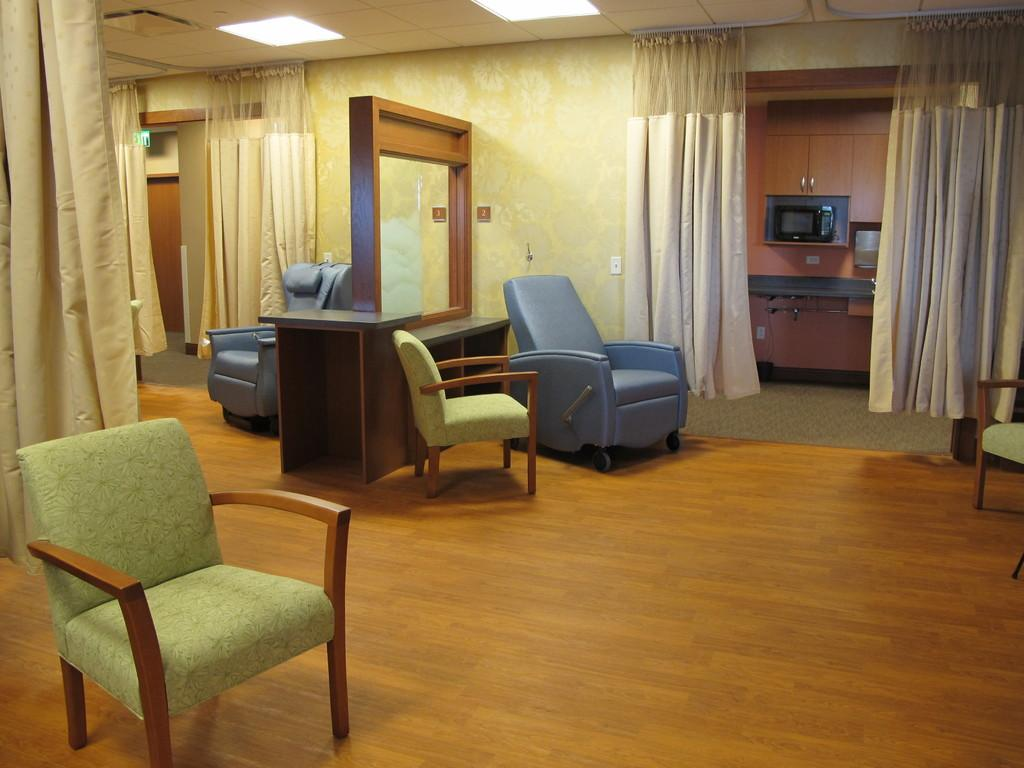What type of furniture is present in the image? There are chairs and a sofa in the image. What type of window treatment is visible in the image? There are curtains in the image. What type of structure is visible in the image? There is a wall in the image. What type of lighting is present in the image? There is a light in the image. Can you describe the kitten that is begging for a sweater in the image? There is no kitten or sweater present in the image. 